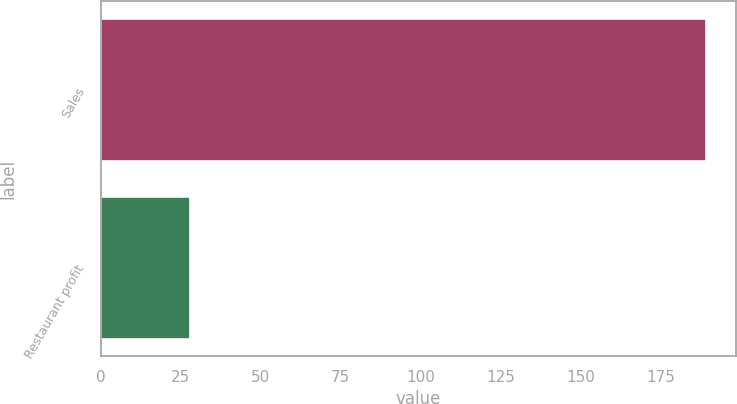Convert chart. <chart><loc_0><loc_0><loc_500><loc_500><bar_chart><fcel>Sales<fcel>Restaurant profit<nl><fcel>189<fcel>28<nl></chart> 